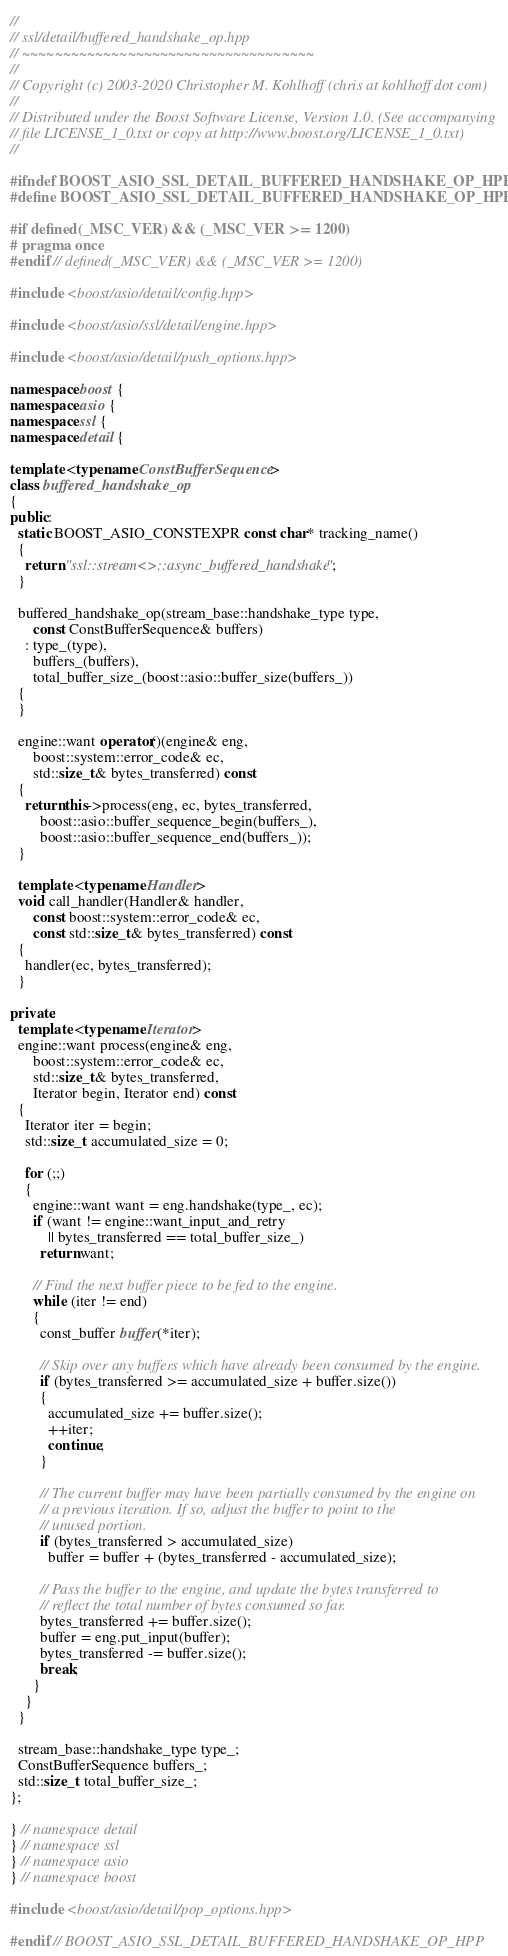Convert code to text. <code><loc_0><loc_0><loc_500><loc_500><_C++_>//
// ssl/detail/buffered_handshake_op.hpp
// ~~~~~~~~~~~~~~~~~~~~~~~~~~~~~~~~~~~~
//
// Copyright (c) 2003-2020 Christopher M. Kohlhoff (chris at kohlhoff dot com)
//
// Distributed under the Boost Software License, Version 1.0. (See accompanying
// file LICENSE_1_0.txt or copy at http://www.boost.org/LICENSE_1_0.txt)
//

#ifndef BOOST_ASIO_SSL_DETAIL_BUFFERED_HANDSHAKE_OP_HPP
#define BOOST_ASIO_SSL_DETAIL_BUFFERED_HANDSHAKE_OP_HPP

#if defined(_MSC_VER) && (_MSC_VER >= 1200)
# pragma once
#endif // defined(_MSC_VER) && (_MSC_VER >= 1200)

#include <boost/asio/detail/config.hpp>

#include <boost/asio/ssl/detail/engine.hpp>

#include <boost/asio/detail/push_options.hpp>

namespace boost {
namespace asio {
namespace ssl {
namespace detail {

template <typename ConstBufferSequence>
class buffered_handshake_op
{
public:
  static BOOST_ASIO_CONSTEXPR const char* tracking_name()
  {
    return "ssl::stream<>::async_buffered_handshake";
  }

  buffered_handshake_op(stream_base::handshake_type type,
      const ConstBufferSequence& buffers)
    : type_(type),
      buffers_(buffers),
      total_buffer_size_(boost::asio::buffer_size(buffers_))
  {
  }

  engine::want operator()(engine& eng,
      boost::system::error_code& ec,
      std::size_t& bytes_transferred) const
  {
    return this->process(eng, ec, bytes_transferred,
        boost::asio::buffer_sequence_begin(buffers_),
        boost::asio::buffer_sequence_end(buffers_));
  }

  template <typename Handler>
  void call_handler(Handler& handler,
      const boost::system::error_code& ec,
      const std::size_t& bytes_transferred) const
  {
    handler(ec, bytes_transferred);
  }

private:
  template <typename Iterator>
  engine::want process(engine& eng,
      boost::system::error_code& ec,
      std::size_t& bytes_transferred,
      Iterator begin, Iterator end) const
  {
    Iterator iter = begin;
    std::size_t accumulated_size = 0;

    for (;;)
    {
      engine::want want = eng.handshake(type_, ec);
      if (want != engine::want_input_and_retry
          || bytes_transferred == total_buffer_size_)
        return want;

      // Find the next buffer piece to be fed to the engine.
      while (iter != end)
      {
        const_buffer buffer(*iter);

        // Skip over any buffers which have already been consumed by the engine.
        if (bytes_transferred >= accumulated_size + buffer.size())
        {
          accumulated_size += buffer.size();
          ++iter;
          continue;
        }

        // The current buffer may have been partially consumed by the engine on
        // a previous iteration. If so, adjust the buffer to point to the
        // unused portion.
        if (bytes_transferred > accumulated_size)
          buffer = buffer + (bytes_transferred - accumulated_size);

        // Pass the buffer to the engine, and update the bytes transferred to
        // reflect the total number of bytes consumed so far.
        bytes_transferred += buffer.size();
        buffer = eng.put_input(buffer);
        bytes_transferred -= buffer.size();
        break;
      }
    }
  }

  stream_base::handshake_type type_;
  ConstBufferSequence buffers_;
  std::size_t total_buffer_size_;
};

} // namespace detail
} // namespace ssl
} // namespace asio
} // namespace boost

#include <boost/asio/detail/pop_options.hpp>

#endif // BOOST_ASIO_SSL_DETAIL_BUFFERED_HANDSHAKE_OP_HPP
</code> 